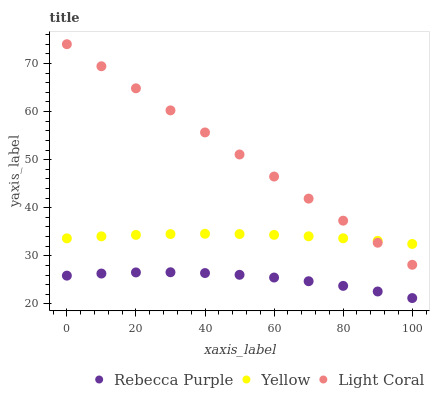Does Rebecca Purple have the minimum area under the curve?
Answer yes or no. Yes. Does Light Coral have the maximum area under the curve?
Answer yes or no. Yes. Does Yellow have the minimum area under the curve?
Answer yes or no. No. Does Yellow have the maximum area under the curve?
Answer yes or no. No. Is Light Coral the smoothest?
Answer yes or no. Yes. Is Rebecca Purple the roughest?
Answer yes or no. Yes. Is Yellow the smoothest?
Answer yes or no. No. Is Yellow the roughest?
Answer yes or no. No. Does Rebecca Purple have the lowest value?
Answer yes or no. Yes. Does Yellow have the lowest value?
Answer yes or no. No. Does Light Coral have the highest value?
Answer yes or no. Yes. Does Yellow have the highest value?
Answer yes or no. No. Is Rebecca Purple less than Yellow?
Answer yes or no. Yes. Is Yellow greater than Rebecca Purple?
Answer yes or no. Yes. Does Yellow intersect Light Coral?
Answer yes or no. Yes. Is Yellow less than Light Coral?
Answer yes or no. No. Is Yellow greater than Light Coral?
Answer yes or no. No. Does Rebecca Purple intersect Yellow?
Answer yes or no. No. 